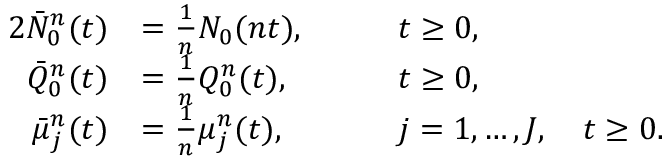<formula> <loc_0><loc_0><loc_500><loc_500>\begin{array} { r l r l } { { 2 } \bar { N } _ { 0 } ^ { n } ( t ) } & { = \frac { 1 } { n } N _ { 0 } ( n t ) , \quad } & & { t \geq 0 , } \\ { \bar { Q } _ { 0 } ^ { n } ( t ) } & { = \frac { 1 } { n } Q _ { 0 } ^ { n } ( t ) , \quad } & & { t \geq 0 , } \\ { \bar { \mu } _ { j } ^ { n } ( t ) } & { = \frac { 1 } { n } \mu _ { j } ^ { n } ( t ) , \quad } & & { j = 1 , \dots , J , \quad t \geq 0 . } \end{array}</formula> 